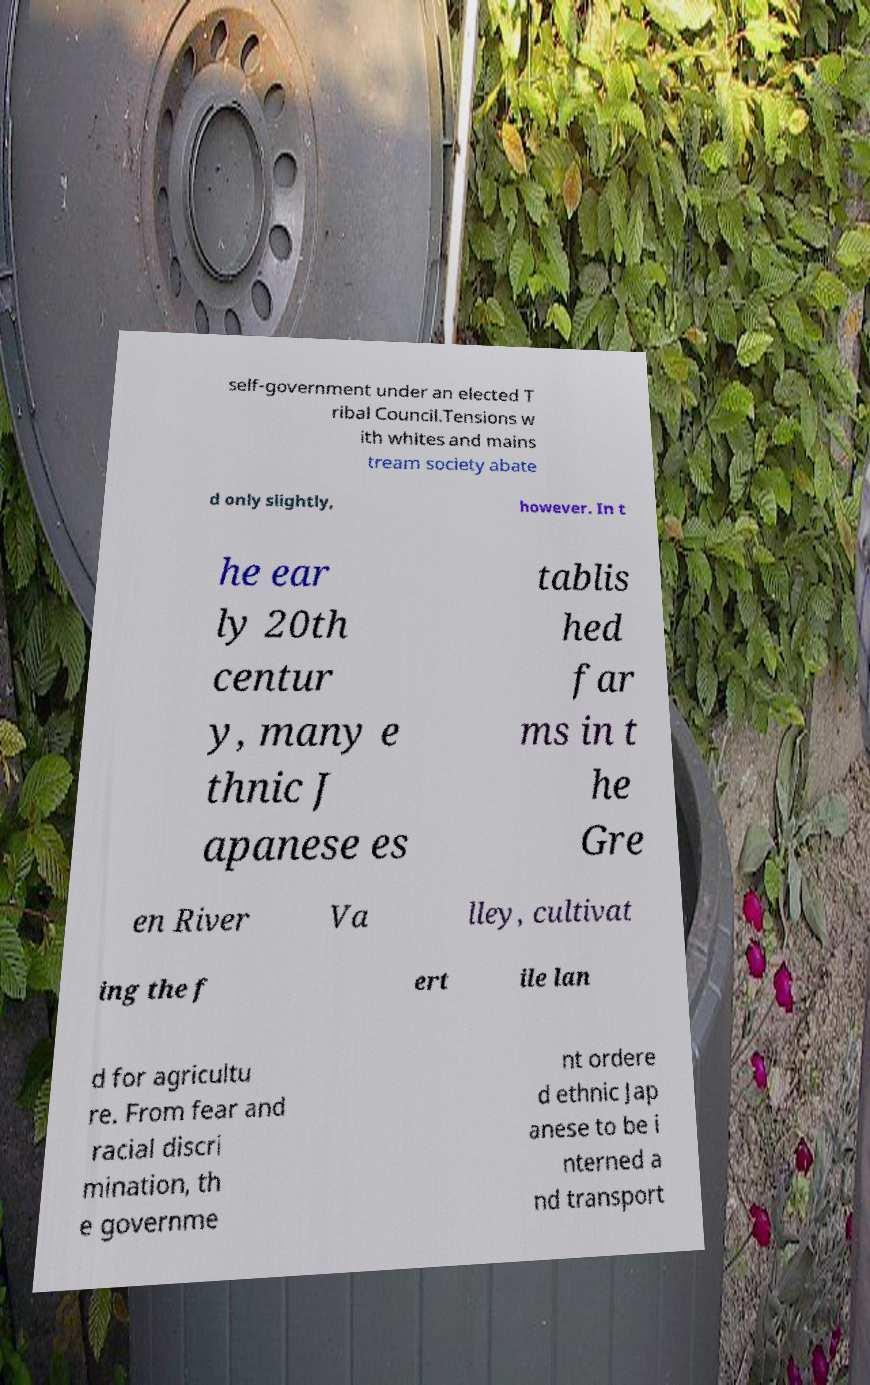For documentation purposes, I need the text within this image transcribed. Could you provide that? self-government under an elected T ribal Council.Tensions w ith whites and mains tream society abate d only slightly, however. In t he ear ly 20th centur y, many e thnic J apanese es tablis hed far ms in t he Gre en River Va lley, cultivat ing the f ert ile lan d for agricultu re. From fear and racial discri mination, th e governme nt ordere d ethnic Jap anese to be i nterned a nd transport 